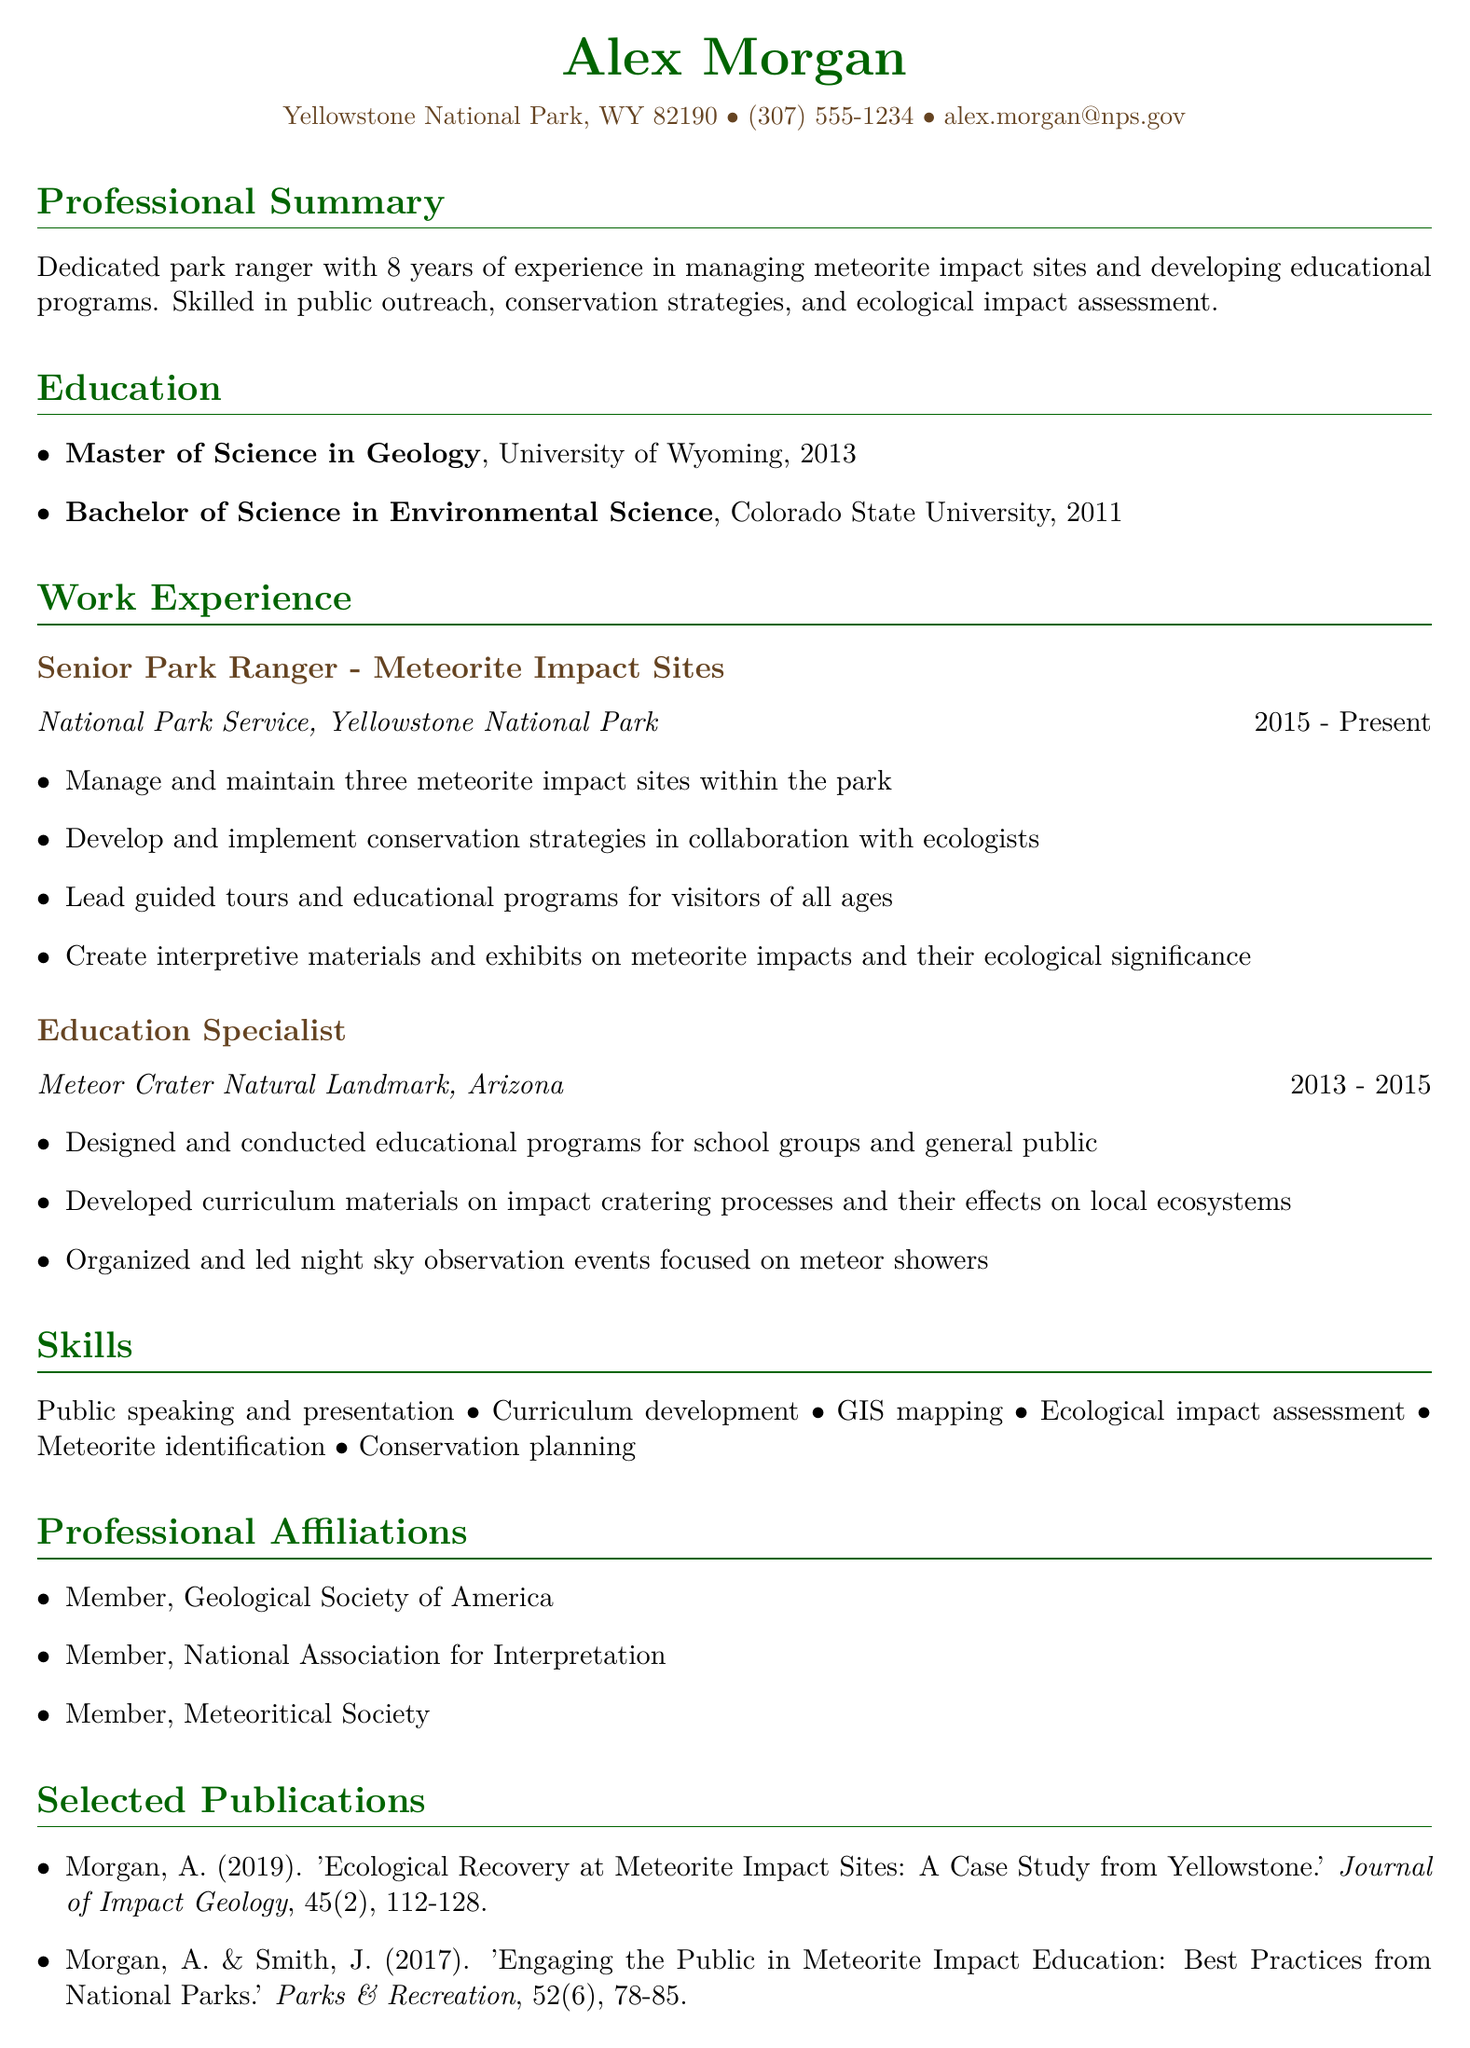What is the name of the individual? The name of the individual is prominently displayed at the top of the document.
Answer: Alex Morgan What is the highest degree obtained? The highest degree is listed in the education section of the document.
Answer: Master of Science in Geology Which institution did the individual attend for their bachelor's degree? The document specifies the institution where the bachelor's degree was obtained.
Answer: Colorado State University In which year did the individual start working as a Senior Park Ranger? The duration of employment is detailed in the work experience section, indicating the start year.
Answer: 2015 How many years of experience does the individual have in public education and outreach? The professional summary states the individual’s years of experience related to their role.
Answer: 8 years What type of events did the individual organize at the Meteor Crater Natural Landmark? The document mentions specific activities organized during the individual’s tenure at that job.
Answer: Night sky observation events Which organization is the individual a member of that focuses on interpretation? The list of professional affiliations provides names of relevant organizations.
Answer: National Association for Interpretation Name one publication authored by the individual. The selected publications section lists works authored by the individual.
Answer: 'Ecological Recovery at Meteorite Impact Sites: A Case Study from Yellowstone' What is one skill listed in the CV? The skills section outlines specific abilities held by the individual.
Answer: Public speaking and presentation 